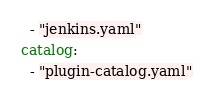Convert code to text. <code><loc_0><loc_0><loc_500><loc_500><_YAML_>  - "jenkins.yaml"
catalog:
  - "plugin-catalog.yaml"
</code> 